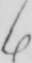What text is written in this handwritten line? 6 . 